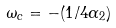<formula> <loc_0><loc_0><loc_500><loc_500>\omega _ { c } = - ( 1 / 4 \alpha _ { 2 } )</formula> 